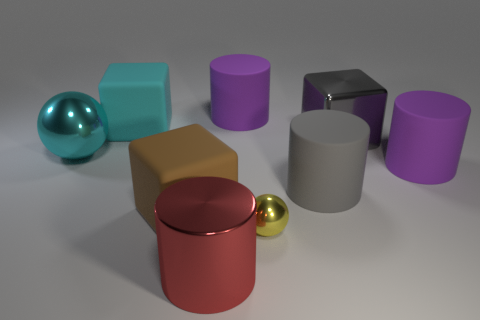There is a big metallic thing that is right of the large purple cylinder that is on the left side of the large gray cylinder; what is its shape?
Make the answer very short. Cube. Is there another large metal thing that has the same shape as the yellow thing?
Offer a terse response. Yes. There is a big shiny ball; is it the same color as the large rubber cube on the left side of the large brown block?
Offer a terse response. Yes. Is there a yellow matte ball that has the same size as the cyan metallic thing?
Offer a very short reply. No. Does the yellow object have the same material as the big gray thing that is behind the large cyan shiny ball?
Make the answer very short. Yes. Is the number of big matte cubes greater than the number of big cubes?
Give a very brief answer. No. What number of cylinders are either yellow objects or big cyan rubber objects?
Keep it short and to the point. 0. What is the color of the metal cylinder?
Make the answer very short. Red. Do the metal ball in front of the brown block and the matte cylinder that is to the left of the gray rubber cylinder have the same size?
Make the answer very short. No. Are there fewer blue cylinders than metallic cylinders?
Ensure brevity in your answer.  Yes. 